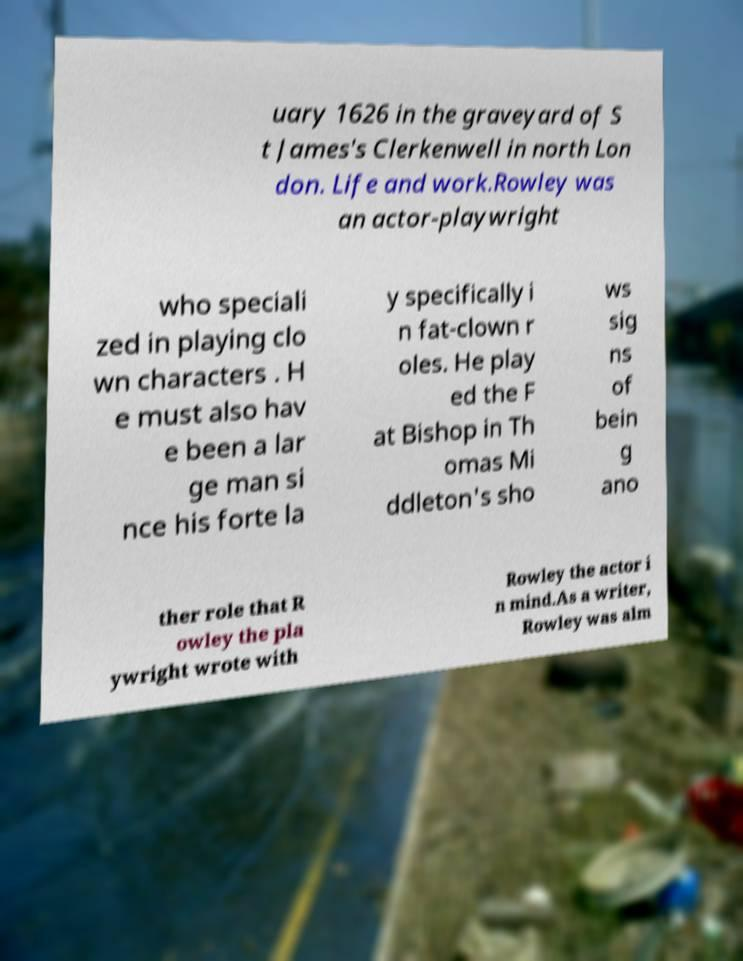Could you assist in decoding the text presented in this image and type it out clearly? uary 1626 in the graveyard of S t James's Clerkenwell in north Lon don. Life and work.Rowley was an actor-playwright who speciali zed in playing clo wn characters . H e must also hav e been a lar ge man si nce his forte la y specifically i n fat-clown r oles. He play ed the F at Bishop in Th omas Mi ddleton's sho ws sig ns of bein g ano ther role that R owley the pla ywright wrote with Rowley the actor i n mind.As a writer, Rowley was alm 